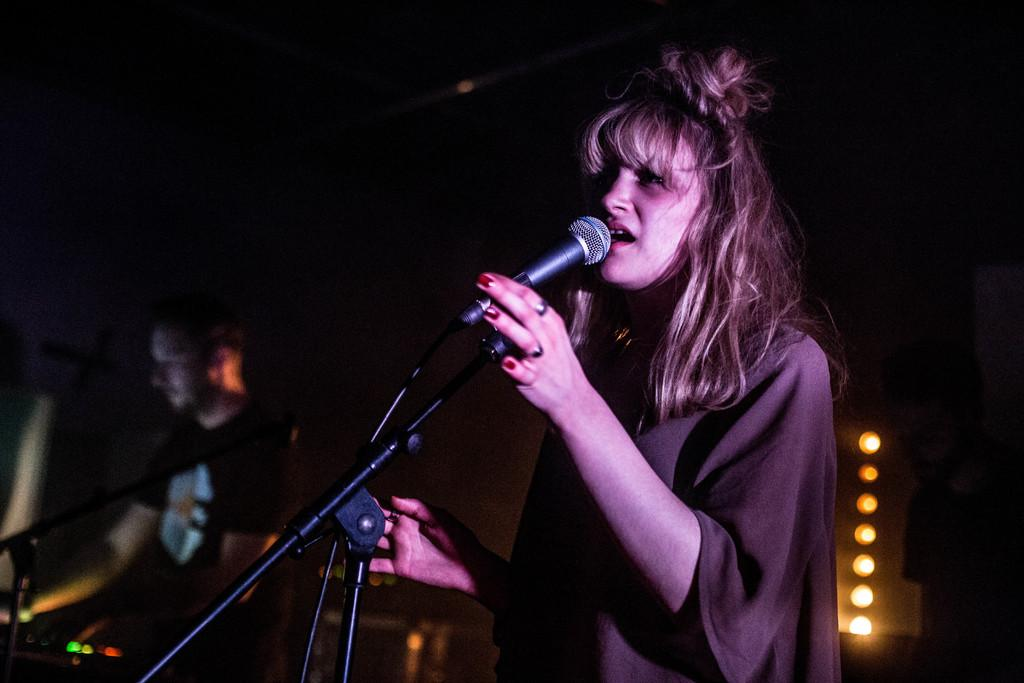Who or what can be seen in the image? There are people in the image. What objects are present that might be used for amplifying sound? There are microphones in the image. What can be seen behind the people and microphones? The background is visible in the image. What can be seen providing illumination in the image? There are lights in the image. What is the rate of the iron's movement along the coast in the image? There is no iron or coast present in the image, so it is not possible to determine the rate of its movement. 